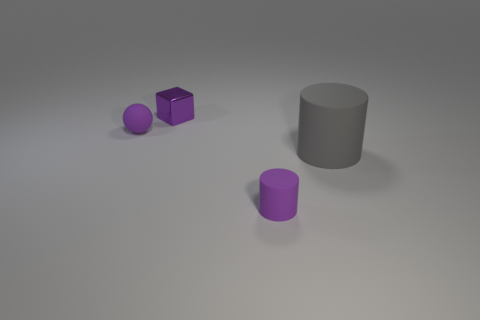Subtract all green cylinders. Subtract all red cubes. How many cylinders are left? 2 Add 2 tiny yellow cubes. How many objects exist? 6 Subtract all spheres. How many objects are left? 3 Add 2 metallic blocks. How many metallic blocks exist? 3 Subtract 0 red blocks. How many objects are left? 4 Subtract all tiny purple matte cylinders. Subtract all tiny cylinders. How many objects are left? 2 Add 2 purple matte cylinders. How many purple matte cylinders are left? 3 